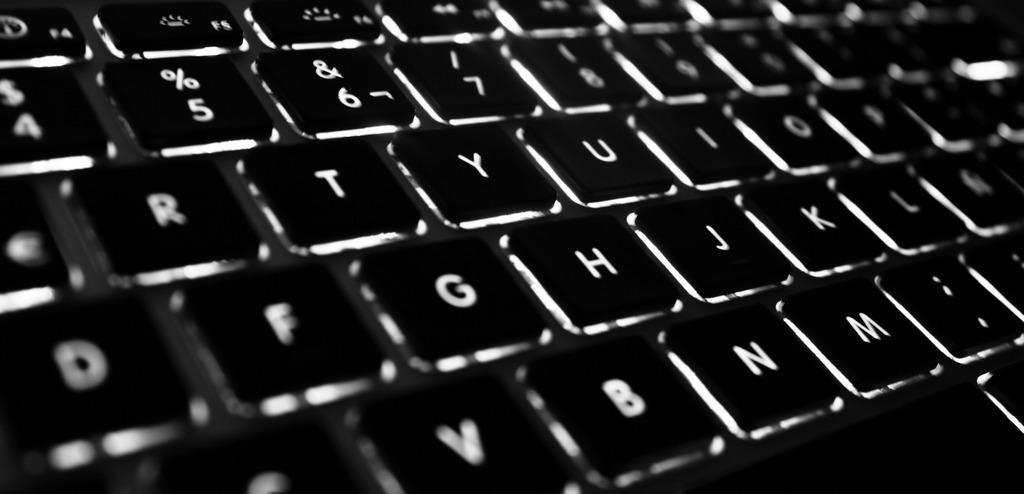What is located in the foreground of the image? There are buttons on a keyboard in the foreground of the image. What types of characters are present on the buttons? The buttons have letters, numbers, and special characters on them. What type of jelly can be seen dripping from the kettle in the image? There is no jelly or kettle present in the image. 